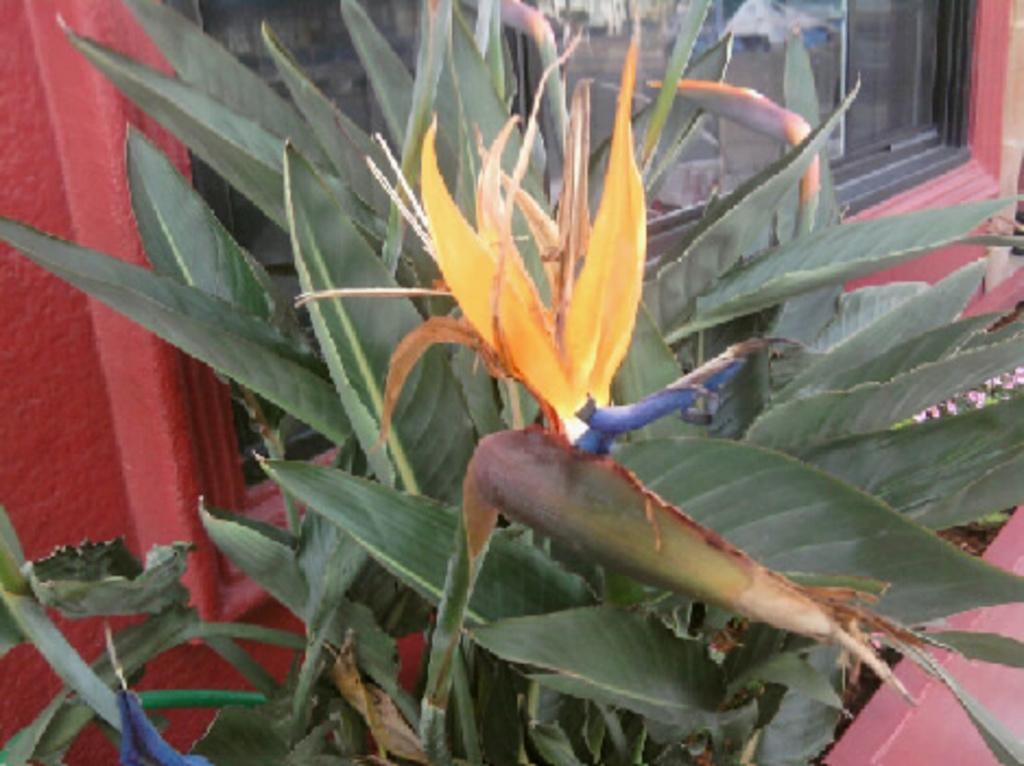What type of vegetation is in the foreground of the image? There are plants in the foreground of the image. What type of architectural feature can be seen in the background of the image? There are glass windows in the background of the image. What book is the person reading in the image? There is no person or book present in the image; it only features plants in the foreground and glass windows in the background. 